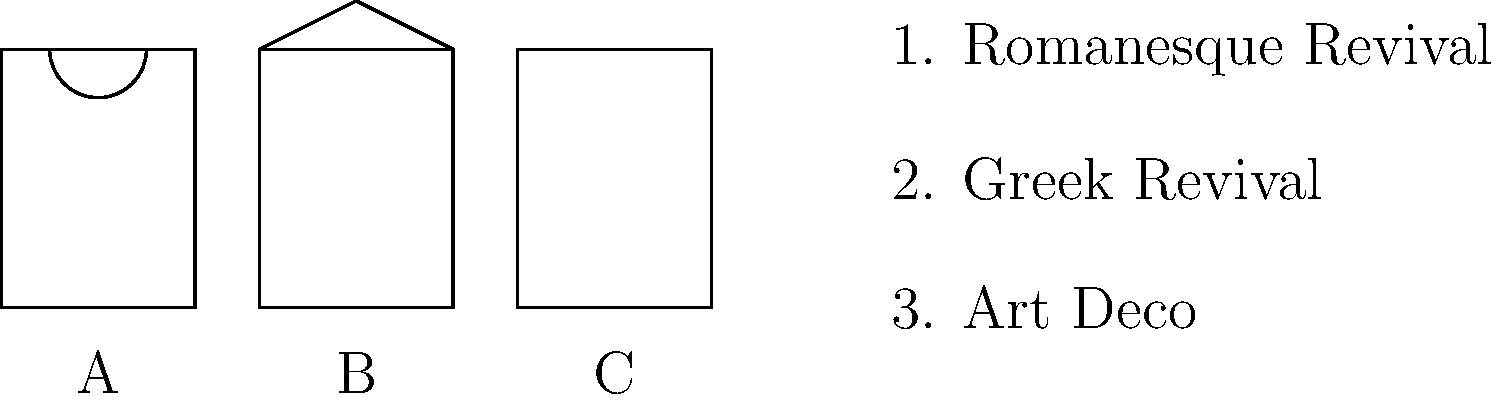Match the silhouettes of historic storefronts (A, B, C) to their corresponding architectural styles (1, 2, 3). Which combination correctly pairs all three storefronts with their styles? To solve this question, we need to analyze the key features of each storefront silhouette and match them to the characteristics of the given architectural styles:

1. Storefront A:
   - Features a rounded arch above the entrance
   - This is a key characteristic of Romanesque Revival architecture

2. Storefront B:
   - Has a triangular pediment above the entrance
   - This is a defining feature of Greek Revival architecture

3. Storefront C:
   - Shows a simple, streamlined facade without ornate details
   - This clean, geometric look is typical of Art Deco architecture

Matching the storefronts to their styles:
A - 1 (Romanesque Revival)
B - 2 (Greek Revival)
C - 3 (Art Deco)

Therefore, the correct combination that pairs all three storefronts with their styles is A1, B2, C3.
Answer: A1, B2, C3 